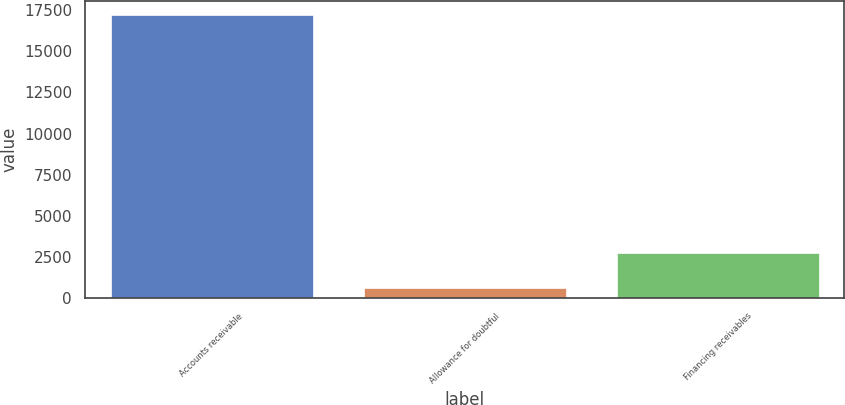Convert chart. <chart><loc_0><loc_0><loc_500><loc_500><bar_chart><fcel>Accounts receivable<fcel>Allowance for doubtful<fcel>Financing receivables<nl><fcel>17166<fcel>629<fcel>2723<nl></chart> 